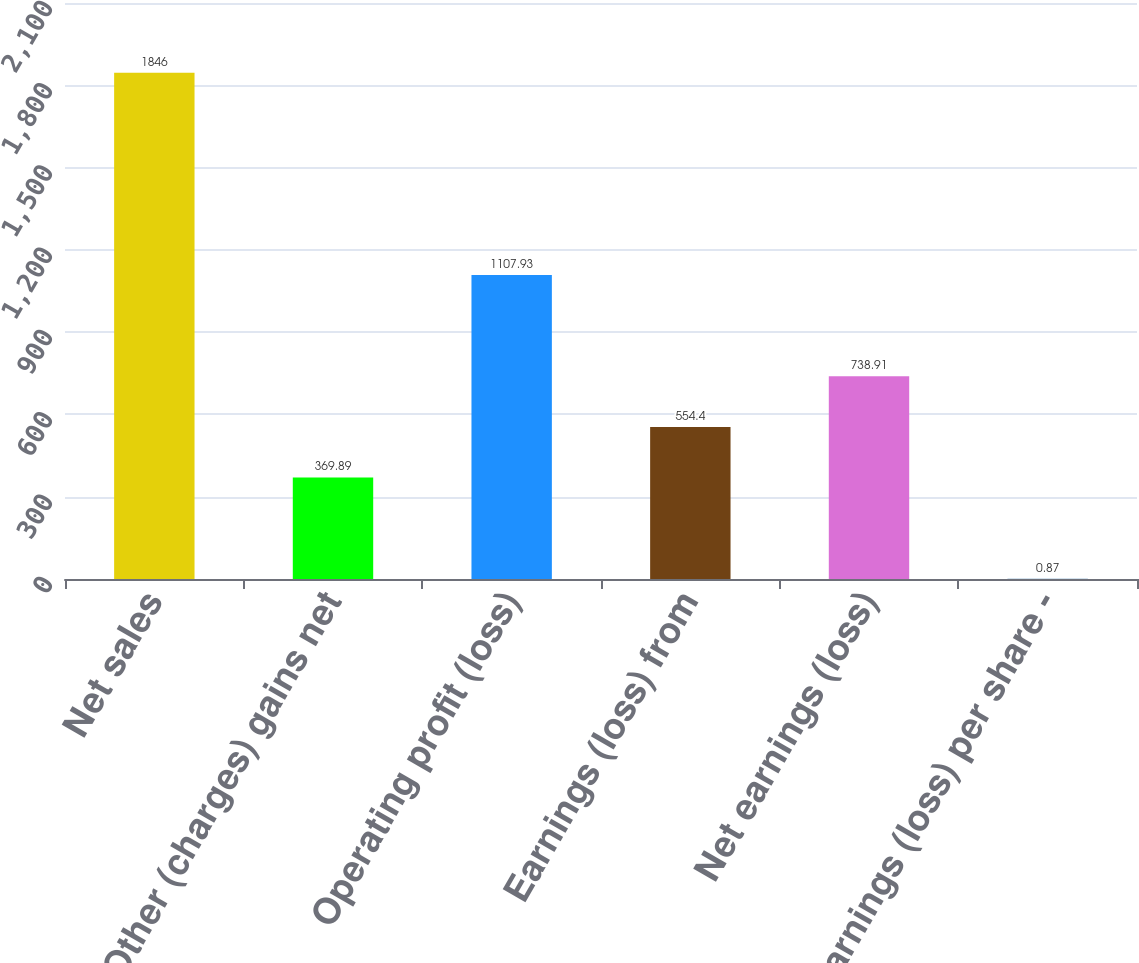Convert chart to OTSL. <chart><loc_0><loc_0><loc_500><loc_500><bar_chart><fcel>Net sales<fcel>Other (charges) gains net<fcel>Operating profit (loss)<fcel>Earnings (loss) from<fcel>Net earnings (loss)<fcel>Earnings (loss) per share -<nl><fcel>1846<fcel>369.89<fcel>1107.93<fcel>554.4<fcel>738.91<fcel>0.87<nl></chart> 